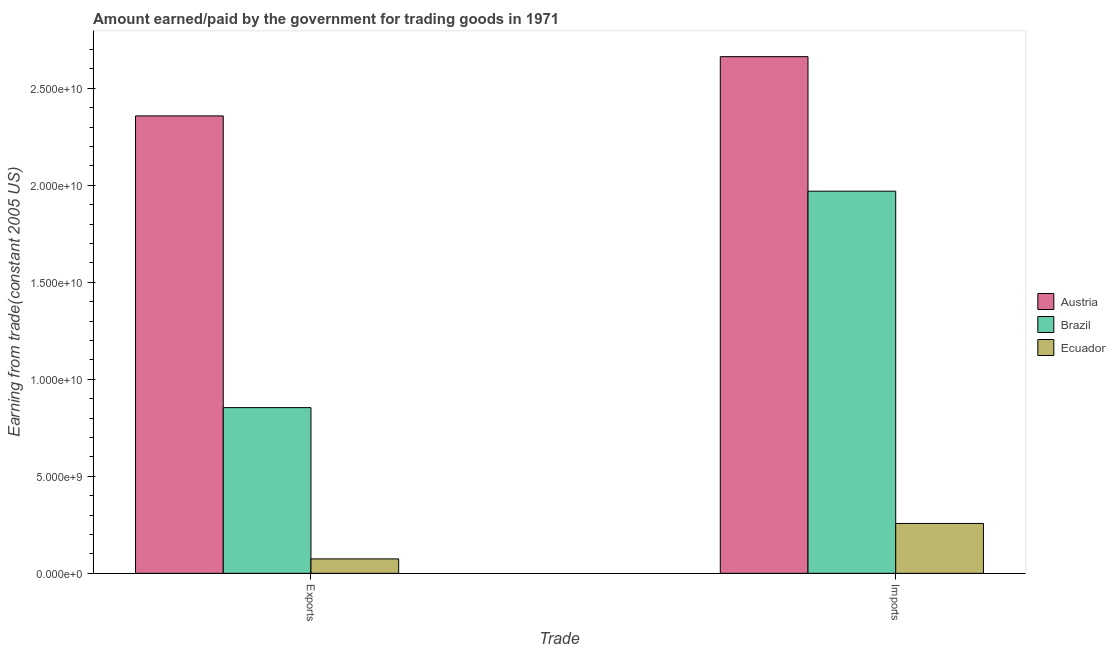How many different coloured bars are there?
Keep it short and to the point. 3. How many groups of bars are there?
Keep it short and to the point. 2. Are the number of bars per tick equal to the number of legend labels?
Provide a short and direct response. Yes. How many bars are there on the 2nd tick from the right?
Make the answer very short. 3. What is the label of the 2nd group of bars from the left?
Your answer should be compact. Imports. What is the amount paid for imports in Brazil?
Offer a very short reply. 1.97e+1. Across all countries, what is the maximum amount paid for imports?
Offer a terse response. 2.66e+1. Across all countries, what is the minimum amount earned from exports?
Provide a short and direct response. 7.44e+08. In which country was the amount paid for imports minimum?
Your response must be concise. Ecuador. What is the total amount paid for imports in the graph?
Make the answer very short. 4.89e+1. What is the difference between the amount earned from exports in Brazil and that in Austria?
Keep it short and to the point. -1.50e+1. What is the difference between the amount earned from exports in Austria and the amount paid for imports in Brazil?
Offer a very short reply. 3.88e+09. What is the average amount paid for imports per country?
Your answer should be very brief. 1.63e+1. What is the difference between the amount earned from exports and amount paid for imports in Brazil?
Your answer should be very brief. -1.12e+1. In how many countries, is the amount earned from exports greater than 17000000000 US$?
Your answer should be very brief. 1. What is the ratio of the amount earned from exports in Brazil to that in Austria?
Offer a very short reply. 0.36. Is the amount earned from exports in Ecuador less than that in Austria?
Keep it short and to the point. Yes. What does the 3rd bar from the right in Exports represents?
Your response must be concise. Austria. How many bars are there?
Offer a very short reply. 6. Are all the bars in the graph horizontal?
Your answer should be compact. No. Are the values on the major ticks of Y-axis written in scientific E-notation?
Ensure brevity in your answer.  Yes. Where does the legend appear in the graph?
Ensure brevity in your answer.  Center right. What is the title of the graph?
Ensure brevity in your answer.  Amount earned/paid by the government for trading goods in 1971. Does "Mauritania" appear as one of the legend labels in the graph?
Offer a very short reply. No. What is the label or title of the X-axis?
Ensure brevity in your answer.  Trade. What is the label or title of the Y-axis?
Give a very brief answer. Earning from trade(constant 2005 US). What is the Earning from trade(constant 2005 US) in Austria in Exports?
Provide a succinct answer. 2.36e+1. What is the Earning from trade(constant 2005 US) of Brazil in Exports?
Provide a succinct answer. 8.54e+09. What is the Earning from trade(constant 2005 US) of Ecuador in Exports?
Provide a succinct answer. 7.44e+08. What is the Earning from trade(constant 2005 US) of Austria in Imports?
Provide a succinct answer. 2.66e+1. What is the Earning from trade(constant 2005 US) in Brazil in Imports?
Your response must be concise. 1.97e+1. What is the Earning from trade(constant 2005 US) in Ecuador in Imports?
Your response must be concise. 2.57e+09. Across all Trade, what is the maximum Earning from trade(constant 2005 US) in Austria?
Ensure brevity in your answer.  2.66e+1. Across all Trade, what is the maximum Earning from trade(constant 2005 US) in Brazil?
Your answer should be very brief. 1.97e+1. Across all Trade, what is the maximum Earning from trade(constant 2005 US) of Ecuador?
Offer a very short reply. 2.57e+09. Across all Trade, what is the minimum Earning from trade(constant 2005 US) in Austria?
Make the answer very short. 2.36e+1. Across all Trade, what is the minimum Earning from trade(constant 2005 US) in Brazil?
Make the answer very short. 8.54e+09. Across all Trade, what is the minimum Earning from trade(constant 2005 US) in Ecuador?
Make the answer very short. 7.44e+08. What is the total Earning from trade(constant 2005 US) in Austria in the graph?
Make the answer very short. 5.02e+1. What is the total Earning from trade(constant 2005 US) in Brazil in the graph?
Ensure brevity in your answer.  2.82e+1. What is the total Earning from trade(constant 2005 US) of Ecuador in the graph?
Your answer should be very brief. 3.31e+09. What is the difference between the Earning from trade(constant 2005 US) of Austria in Exports and that in Imports?
Your response must be concise. -3.05e+09. What is the difference between the Earning from trade(constant 2005 US) of Brazil in Exports and that in Imports?
Make the answer very short. -1.12e+1. What is the difference between the Earning from trade(constant 2005 US) of Ecuador in Exports and that in Imports?
Provide a succinct answer. -1.83e+09. What is the difference between the Earning from trade(constant 2005 US) in Austria in Exports and the Earning from trade(constant 2005 US) in Brazil in Imports?
Your response must be concise. 3.88e+09. What is the difference between the Earning from trade(constant 2005 US) in Austria in Exports and the Earning from trade(constant 2005 US) in Ecuador in Imports?
Give a very brief answer. 2.10e+1. What is the difference between the Earning from trade(constant 2005 US) of Brazil in Exports and the Earning from trade(constant 2005 US) of Ecuador in Imports?
Provide a succinct answer. 5.97e+09. What is the average Earning from trade(constant 2005 US) in Austria per Trade?
Offer a terse response. 2.51e+1. What is the average Earning from trade(constant 2005 US) of Brazil per Trade?
Offer a terse response. 1.41e+1. What is the average Earning from trade(constant 2005 US) in Ecuador per Trade?
Offer a very short reply. 1.66e+09. What is the difference between the Earning from trade(constant 2005 US) of Austria and Earning from trade(constant 2005 US) of Brazil in Exports?
Keep it short and to the point. 1.50e+1. What is the difference between the Earning from trade(constant 2005 US) of Austria and Earning from trade(constant 2005 US) of Ecuador in Exports?
Offer a very short reply. 2.28e+1. What is the difference between the Earning from trade(constant 2005 US) of Brazil and Earning from trade(constant 2005 US) of Ecuador in Exports?
Provide a short and direct response. 7.80e+09. What is the difference between the Earning from trade(constant 2005 US) in Austria and Earning from trade(constant 2005 US) in Brazil in Imports?
Give a very brief answer. 6.93e+09. What is the difference between the Earning from trade(constant 2005 US) of Austria and Earning from trade(constant 2005 US) of Ecuador in Imports?
Offer a terse response. 2.41e+1. What is the difference between the Earning from trade(constant 2005 US) of Brazil and Earning from trade(constant 2005 US) of Ecuador in Imports?
Your answer should be very brief. 1.71e+1. What is the ratio of the Earning from trade(constant 2005 US) of Austria in Exports to that in Imports?
Provide a short and direct response. 0.89. What is the ratio of the Earning from trade(constant 2005 US) in Brazil in Exports to that in Imports?
Your answer should be very brief. 0.43. What is the ratio of the Earning from trade(constant 2005 US) of Ecuador in Exports to that in Imports?
Offer a very short reply. 0.29. What is the difference between the highest and the second highest Earning from trade(constant 2005 US) of Austria?
Offer a terse response. 3.05e+09. What is the difference between the highest and the second highest Earning from trade(constant 2005 US) in Brazil?
Keep it short and to the point. 1.12e+1. What is the difference between the highest and the second highest Earning from trade(constant 2005 US) in Ecuador?
Make the answer very short. 1.83e+09. What is the difference between the highest and the lowest Earning from trade(constant 2005 US) in Austria?
Keep it short and to the point. 3.05e+09. What is the difference between the highest and the lowest Earning from trade(constant 2005 US) in Brazil?
Keep it short and to the point. 1.12e+1. What is the difference between the highest and the lowest Earning from trade(constant 2005 US) of Ecuador?
Your answer should be very brief. 1.83e+09. 